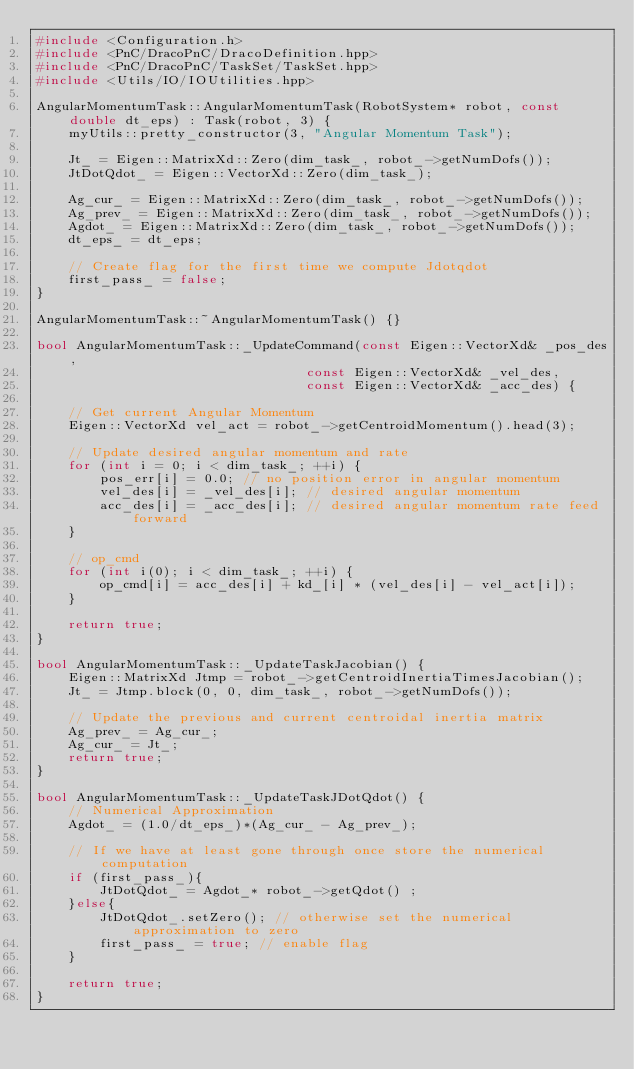<code> <loc_0><loc_0><loc_500><loc_500><_C++_>#include <Configuration.h>
#include <PnC/DracoPnC/DracoDefinition.hpp>
#include <PnC/DracoPnC/TaskSet/TaskSet.hpp>
#include <Utils/IO/IOUtilities.hpp>

AngularMomentumTask::AngularMomentumTask(RobotSystem* robot, const double dt_eps) : Task(robot, 3) {
    myUtils::pretty_constructor(3, "Angular Momentum Task");

    Jt_ = Eigen::MatrixXd::Zero(dim_task_, robot_->getNumDofs());
    JtDotQdot_ = Eigen::VectorXd::Zero(dim_task_);

	Ag_cur_ = Eigen::MatrixXd::Zero(dim_task_, robot_->getNumDofs());
    Ag_prev_ = Eigen::MatrixXd::Zero(dim_task_, robot_->getNumDofs());
    Agdot_ = Eigen::MatrixXd::Zero(dim_task_, robot_->getNumDofs());
    dt_eps_ = dt_eps;

    // Create flag for the first time we compute Jdotqdot
	first_pass_ = false;
}

AngularMomentumTask::~AngularMomentumTask() {}

bool AngularMomentumTask::_UpdateCommand(const Eigen::VectorXd& _pos_des,
                                  const Eigen::VectorXd& _vel_des,
                                  const Eigen::VectorXd& _acc_des) {

	// Get current Angular Momentum
    Eigen::VectorXd vel_act = robot_->getCentroidMomentum().head(3);

	// Update desired angular momentum and rate
    for (int i = 0; i < dim_task_; ++i) {
        pos_err[i] = 0.0; // no position error in angular momentum
        vel_des[i] = _vel_des[i]; // desired angular momentum
        acc_des[i] = _acc_des[i]; // desired angular momentum rate feed forward
    }

    // op_cmd
    for (int i(0); i < dim_task_; ++i) {
        op_cmd[i] = acc_des[i] + kd_[i] * (vel_des[i] - vel_act[i]);
    }

    return true;
}

bool AngularMomentumTask::_UpdateTaskJacobian() {
    Eigen::MatrixXd Jtmp = robot_->getCentroidInertiaTimesJacobian();
    Jt_ = Jtmp.block(0, 0, dim_task_, robot_->getNumDofs());

    // Update the previous and current centroidal inertia matrix
    Ag_prev_ = Ag_cur_;
    Ag_cur_ = Jt_;
    return true;
}

bool AngularMomentumTask::_UpdateTaskJDotQdot() {
	// Numerical Approximation
	Agdot_ = (1.0/dt_eps_)*(Ag_cur_ - Ag_prev_); 

	// If we have at least gone through once store the numerical computation
	if (first_pass_){
    	JtDotQdot_ = Agdot_* robot_->getQdot() ;
	}else{
		JtDotQdot_.setZero(); // otherwise set the numerical approximation to zero
		first_pass_ = true; // enable flag
	}

    return true;
}</code> 